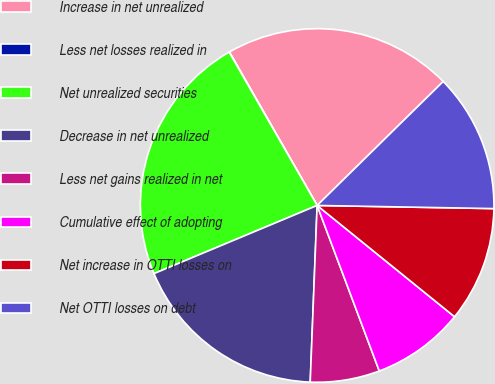Convert chart. <chart><loc_0><loc_0><loc_500><loc_500><pie_chart><fcel>Increase in net unrealized<fcel>Less net losses realized in<fcel>Net unrealized securities<fcel>Decrease in net unrealized<fcel>Less net gains realized in net<fcel>Cumulative effect of adopting<fcel>Net increase in OTTI losses on<fcel>Net OTTI losses on debt<nl><fcel>20.9%<fcel>0.03%<fcel>23.0%<fcel>18.08%<fcel>6.34%<fcel>8.45%<fcel>10.55%<fcel>12.65%<nl></chart> 